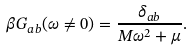Convert formula to latex. <formula><loc_0><loc_0><loc_500><loc_500>\beta G _ { a b } ( \omega \neq 0 ) = \frac { \delta _ { a b } } { M \omega ^ { 2 } + \mu } .</formula> 